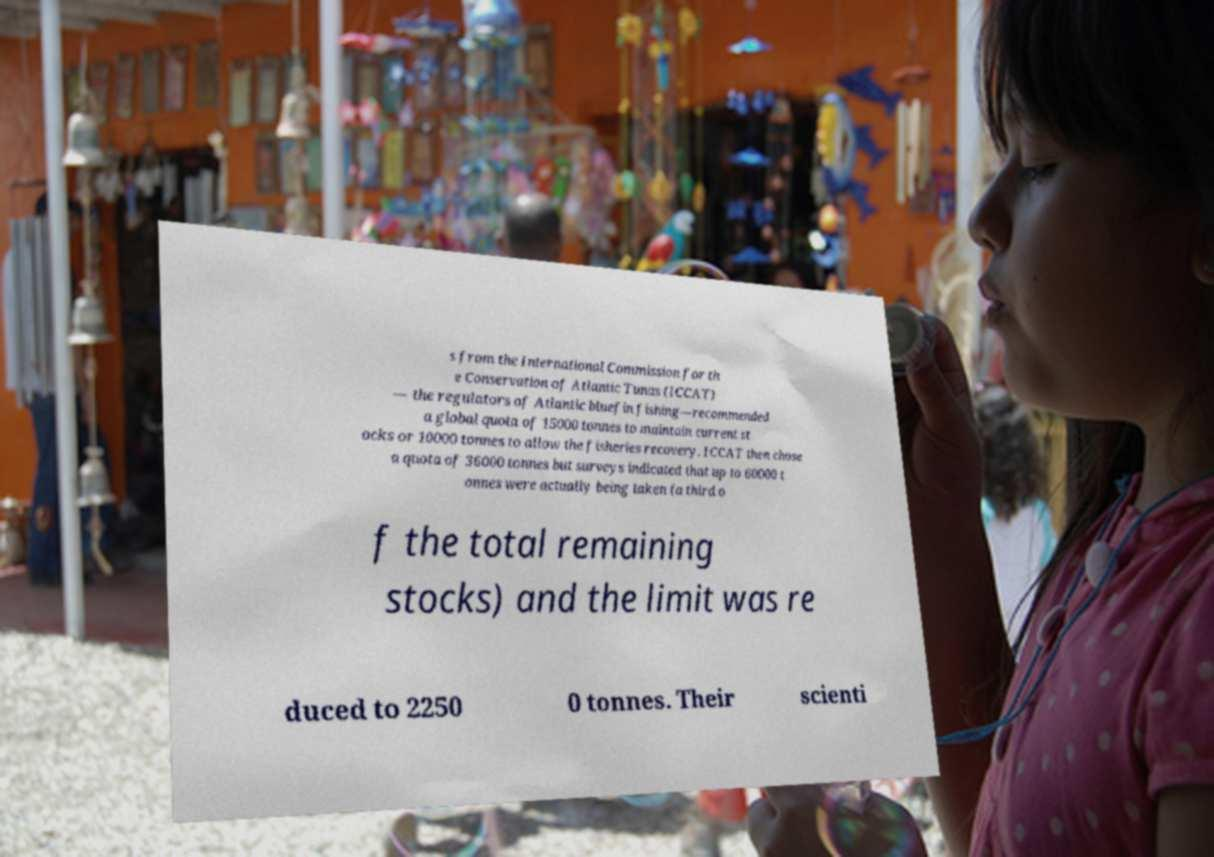Please identify and transcribe the text found in this image. s from the International Commission for th e Conservation of Atlantic Tunas (ICCAT) — the regulators of Atlantic bluefin fishing—recommended a global quota of 15000 tonnes to maintain current st ocks or 10000 tonnes to allow the fisheries recovery. ICCAT then chose a quota of 36000 tonnes but surveys indicated that up to 60000 t onnes were actually being taken (a third o f the total remaining stocks) and the limit was re duced to 2250 0 tonnes. Their scienti 